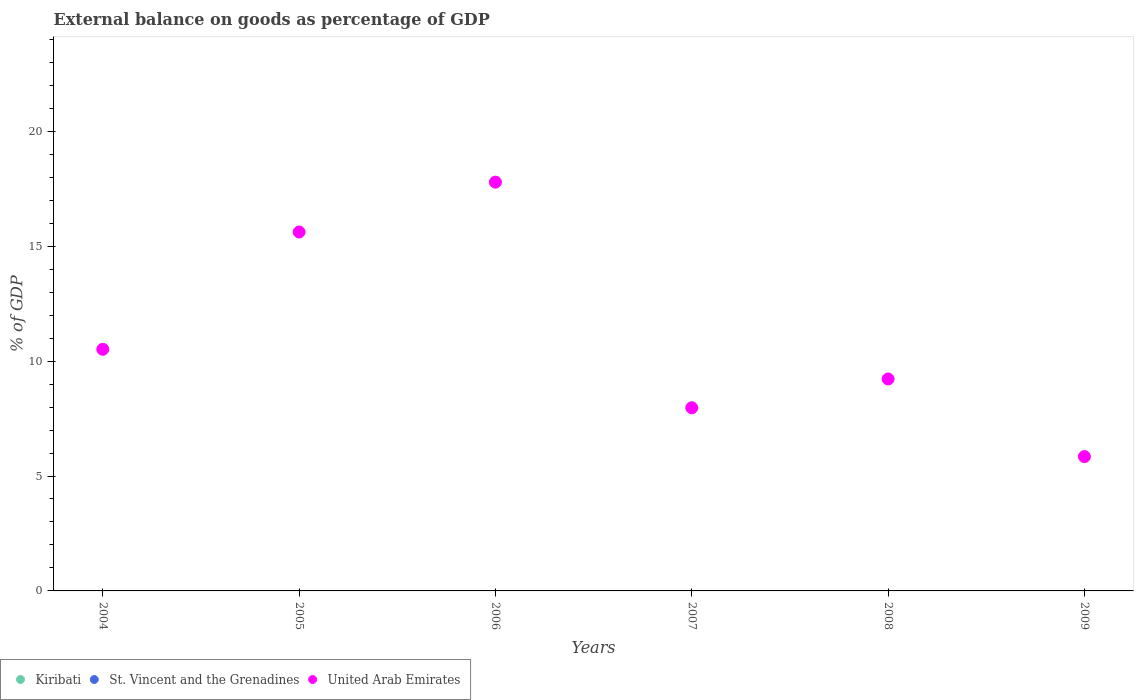What is the external balance on goods as percentage of GDP in United Arab Emirates in 2008?
Provide a short and direct response. 9.22. Across all years, what is the maximum external balance on goods as percentage of GDP in United Arab Emirates?
Provide a short and direct response. 17.79. Across all years, what is the minimum external balance on goods as percentage of GDP in United Arab Emirates?
Keep it short and to the point. 5.84. What is the total external balance on goods as percentage of GDP in United Arab Emirates in the graph?
Your response must be concise. 66.95. What is the difference between the external balance on goods as percentage of GDP in United Arab Emirates in 2005 and that in 2007?
Your answer should be compact. 7.65. What is the average external balance on goods as percentage of GDP in United Arab Emirates per year?
Keep it short and to the point. 11.16. What is the ratio of the external balance on goods as percentage of GDP in United Arab Emirates in 2007 to that in 2009?
Keep it short and to the point. 1.36. What is the difference between the highest and the second highest external balance on goods as percentage of GDP in United Arab Emirates?
Ensure brevity in your answer.  2.17. What is the difference between the highest and the lowest external balance on goods as percentage of GDP in United Arab Emirates?
Your answer should be compact. 11.94. Does the external balance on goods as percentage of GDP in St. Vincent and the Grenadines monotonically increase over the years?
Give a very brief answer. No. Is the external balance on goods as percentage of GDP in St. Vincent and the Grenadines strictly less than the external balance on goods as percentage of GDP in Kiribati over the years?
Offer a terse response. No. How many dotlines are there?
Offer a very short reply. 1. How many years are there in the graph?
Ensure brevity in your answer.  6. What is the difference between two consecutive major ticks on the Y-axis?
Provide a succinct answer. 5. Are the values on the major ticks of Y-axis written in scientific E-notation?
Keep it short and to the point. No. How many legend labels are there?
Offer a very short reply. 3. How are the legend labels stacked?
Your answer should be compact. Horizontal. What is the title of the graph?
Give a very brief answer. External balance on goods as percentage of GDP. What is the label or title of the X-axis?
Your answer should be very brief. Years. What is the label or title of the Y-axis?
Your response must be concise. % of GDP. What is the % of GDP in Kiribati in 2004?
Provide a short and direct response. 0. What is the % of GDP of St. Vincent and the Grenadines in 2004?
Provide a short and direct response. 0. What is the % of GDP of United Arab Emirates in 2004?
Offer a very short reply. 10.51. What is the % of GDP of Kiribati in 2005?
Make the answer very short. 0. What is the % of GDP in St. Vincent and the Grenadines in 2005?
Offer a very short reply. 0. What is the % of GDP in United Arab Emirates in 2005?
Offer a very short reply. 15.62. What is the % of GDP in Kiribati in 2006?
Your answer should be very brief. 0. What is the % of GDP in United Arab Emirates in 2006?
Ensure brevity in your answer.  17.79. What is the % of GDP in St. Vincent and the Grenadines in 2007?
Your response must be concise. 0. What is the % of GDP in United Arab Emirates in 2007?
Your answer should be very brief. 7.97. What is the % of GDP in Kiribati in 2008?
Keep it short and to the point. 0. What is the % of GDP in United Arab Emirates in 2008?
Your response must be concise. 9.22. What is the % of GDP in Kiribati in 2009?
Give a very brief answer. 0. What is the % of GDP in St. Vincent and the Grenadines in 2009?
Offer a very short reply. 0. What is the % of GDP in United Arab Emirates in 2009?
Offer a terse response. 5.84. Across all years, what is the maximum % of GDP in United Arab Emirates?
Keep it short and to the point. 17.79. Across all years, what is the minimum % of GDP of United Arab Emirates?
Your answer should be very brief. 5.84. What is the total % of GDP of Kiribati in the graph?
Offer a very short reply. 0. What is the total % of GDP in St. Vincent and the Grenadines in the graph?
Offer a very short reply. 0. What is the total % of GDP in United Arab Emirates in the graph?
Provide a succinct answer. 66.95. What is the difference between the % of GDP of United Arab Emirates in 2004 and that in 2005?
Provide a succinct answer. -5.1. What is the difference between the % of GDP in United Arab Emirates in 2004 and that in 2006?
Your answer should be compact. -7.27. What is the difference between the % of GDP of United Arab Emirates in 2004 and that in 2007?
Your answer should be compact. 2.54. What is the difference between the % of GDP in United Arab Emirates in 2004 and that in 2008?
Your answer should be compact. 1.29. What is the difference between the % of GDP of United Arab Emirates in 2004 and that in 2009?
Your answer should be compact. 4.67. What is the difference between the % of GDP in United Arab Emirates in 2005 and that in 2006?
Offer a terse response. -2.17. What is the difference between the % of GDP of United Arab Emirates in 2005 and that in 2007?
Your answer should be compact. 7.65. What is the difference between the % of GDP in United Arab Emirates in 2005 and that in 2008?
Your answer should be compact. 6.4. What is the difference between the % of GDP in United Arab Emirates in 2005 and that in 2009?
Ensure brevity in your answer.  9.77. What is the difference between the % of GDP in United Arab Emirates in 2006 and that in 2007?
Provide a succinct answer. 9.82. What is the difference between the % of GDP of United Arab Emirates in 2006 and that in 2008?
Ensure brevity in your answer.  8.56. What is the difference between the % of GDP in United Arab Emirates in 2006 and that in 2009?
Provide a succinct answer. 11.94. What is the difference between the % of GDP of United Arab Emirates in 2007 and that in 2008?
Your answer should be very brief. -1.25. What is the difference between the % of GDP in United Arab Emirates in 2007 and that in 2009?
Ensure brevity in your answer.  2.13. What is the difference between the % of GDP in United Arab Emirates in 2008 and that in 2009?
Offer a very short reply. 3.38. What is the average % of GDP in Kiribati per year?
Your response must be concise. 0. What is the average % of GDP of United Arab Emirates per year?
Offer a terse response. 11.16. What is the ratio of the % of GDP in United Arab Emirates in 2004 to that in 2005?
Your response must be concise. 0.67. What is the ratio of the % of GDP of United Arab Emirates in 2004 to that in 2006?
Give a very brief answer. 0.59. What is the ratio of the % of GDP in United Arab Emirates in 2004 to that in 2007?
Make the answer very short. 1.32. What is the ratio of the % of GDP in United Arab Emirates in 2004 to that in 2008?
Provide a succinct answer. 1.14. What is the ratio of the % of GDP of United Arab Emirates in 2004 to that in 2009?
Your answer should be compact. 1.8. What is the ratio of the % of GDP of United Arab Emirates in 2005 to that in 2006?
Your answer should be compact. 0.88. What is the ratio of the % of GDP in United Arab Emirates in 2005 to that in 2007?
Provide a short and direct response. 1.96. What is the ratio of the % of GDP in United Arab Emirates in 2005 to that in 2008?
Offer a terse response. 1.69. What is the ratio of the % of GDP in United Arab Emirates in 2005 to that in 2009?
Your answer should be compact. 2.67. What is the ratio of the % of GDP in United Arab Emirates in 2006 to that in 2007?
Ensure brevity in your answer.  2.23. What is the ratio of the % of GDP in United Arab Emirates in 2006 to that in 2008?
Provide a short and direct response. 1.93. What is the ratio of the % of GDP of United Arab Emirates in 2006 to that in 2009?
Provide a succinct answer. 3.04. What is the ratio of the % of GDP of United Arab Emirates in 2007 to that in 2008?
Your answer should be very brief. 0.86. What is the ratio of the % of GDP in United Arab Emirates in 2007 to that in 2009?
Your answer should be very brief. 1.36. What is the ratio of the % of GDP of United Arab Emirates in 2008 to that in 2009?
Your response must be concise. 1.58. What is the difference between the highest and the second highest % of GDP of United Arab Emirates?
Ensure brevity in your answer.  2.17. What is the difference between the highest and the lowest % of GDP of United Arab Emirates?
Your answer should be compact. 11.94. 